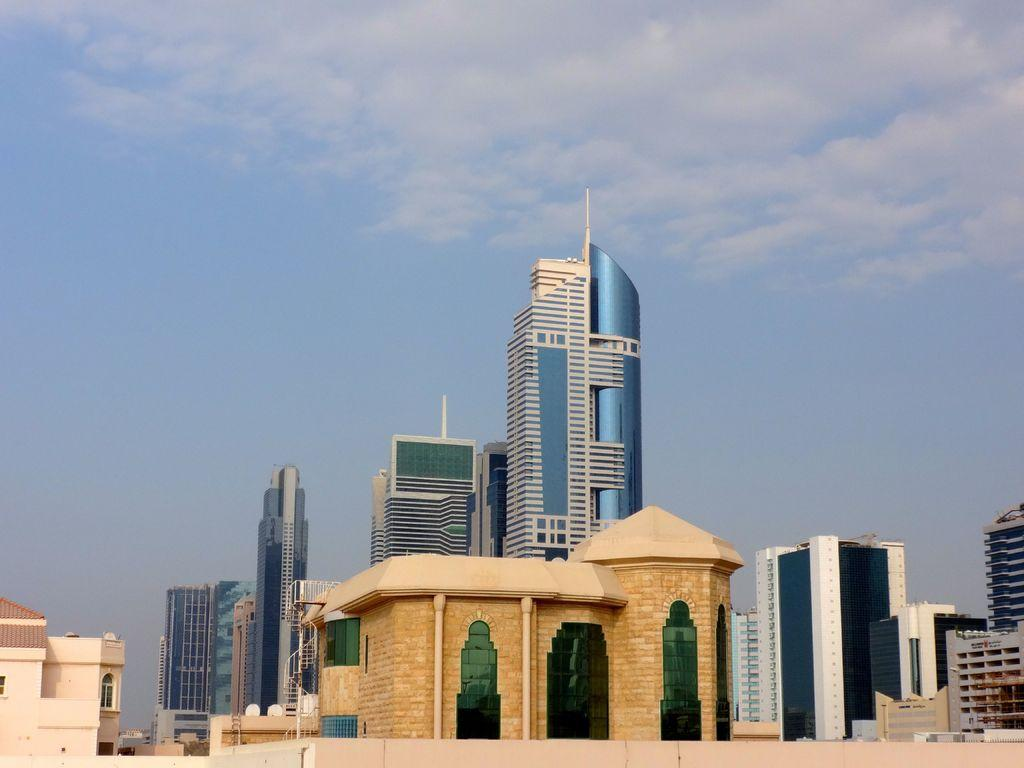What type of structures are located at the bottom of the image? There are buildings at the bottom of the image. What features can be seen on the buildings? The buildings have windows and glass doors. What else is visible in the image besides the buildings? Poles are visible in the image. What can be seen in the background of the image? There are clouds in the sky in the background of the image. What type of dress are the girls wearing in the image? There are no girls or dresses present in the image. 